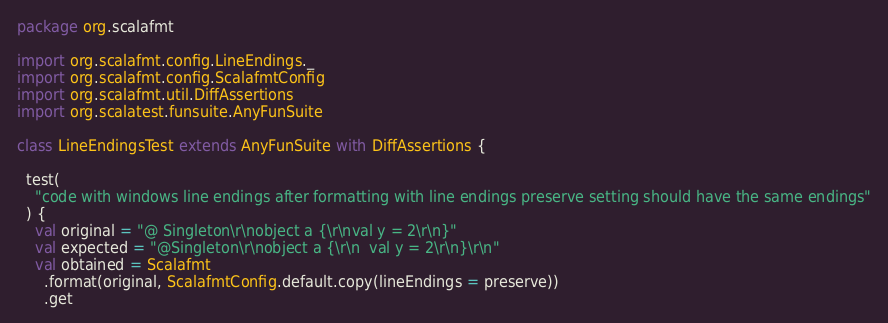<code> <loc_0><loc_0><loc_500><loc_500><_Scala_>package org.scalafmt

import org.scalafmt.config.LineEndings._
import org.scalafmt.config.ScalafmtConfig
import org.scalafmt.util.DiffAssertions
import org.scalatest.funsuite.AnyFunSuite

class LineEndingsTest extends AnyFunSuite with DiffAssertions {

  test(
    "code with windows line endings after formatting with line endings preserve setting should have the same endings"
  ) {
    val original = "@ Singleton\r\nobject a {\r\nval y = 2\r\n}"
    val expected = "@Singleton\r\nobject a {\r\n  val y = 2\r\n}\r\n"
    val obtained = Scalafmt
      .format(original, ScalafmtConfig.default.copy(lineEndings = preserve))
      .get</code> 